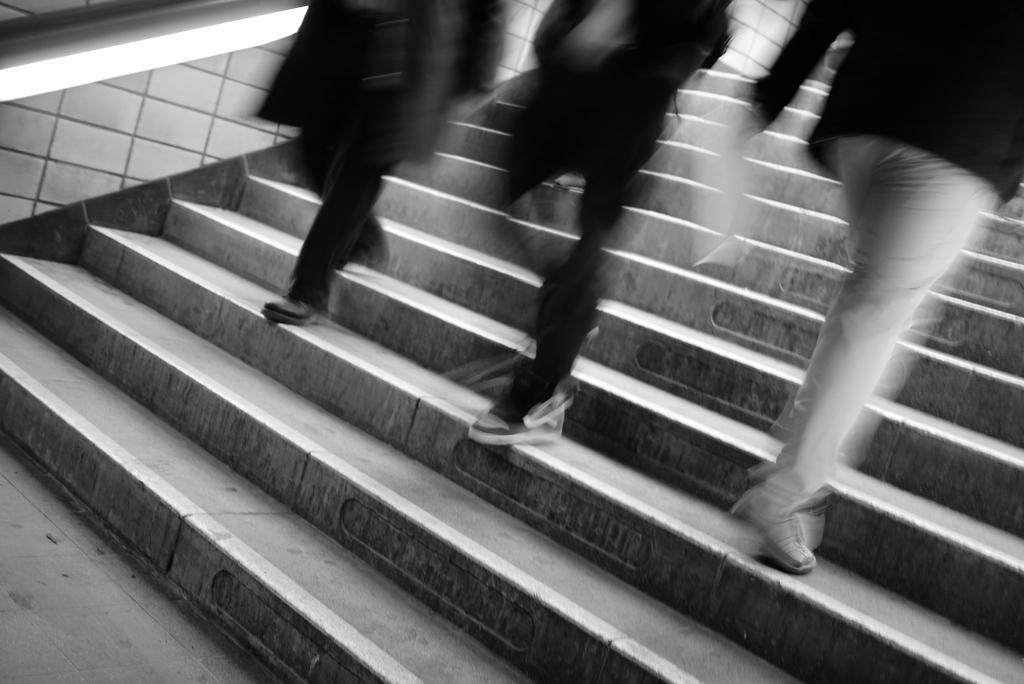In one or two sentences, can you explain what this image depicts? This is a black and white picture. Here we can see three persons on the steps. 